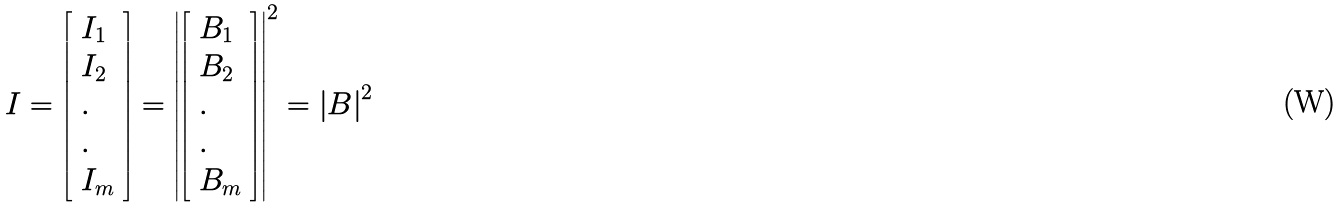Convert formula to latex. <formula><loc_0><loc_0><loc_500><loc_500>I = \left [ \begin{array} l I _ { 1 } \\ I _ { 2 } \\ . \\ . \\ I _ { m } \\ \end{array} \right ] = \left | \left [ \begin{array} l B _ { 1 } \\ B _ { 2 } \\ . \\ . \\ B _ { m } \\ \end{array} \right ] \right | ^ { 2 } = \left | B \right | ^ { 2 }</formula> 